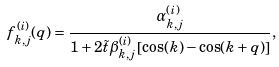Convert formula to latex. <formula><loc_0><loc_0><loc_500><loc_500>f ^ { ( i ) } _ { k , j } ( q ) = \frac { \alpha ^ { ( i ) } _ { k , j } } { 1 + 2 \tilde { t } \beta ^ { ( i ) } _ { k , j } \left [ \cos ( k ) - \cos ( k + q ) \right ] } ,</formula> 